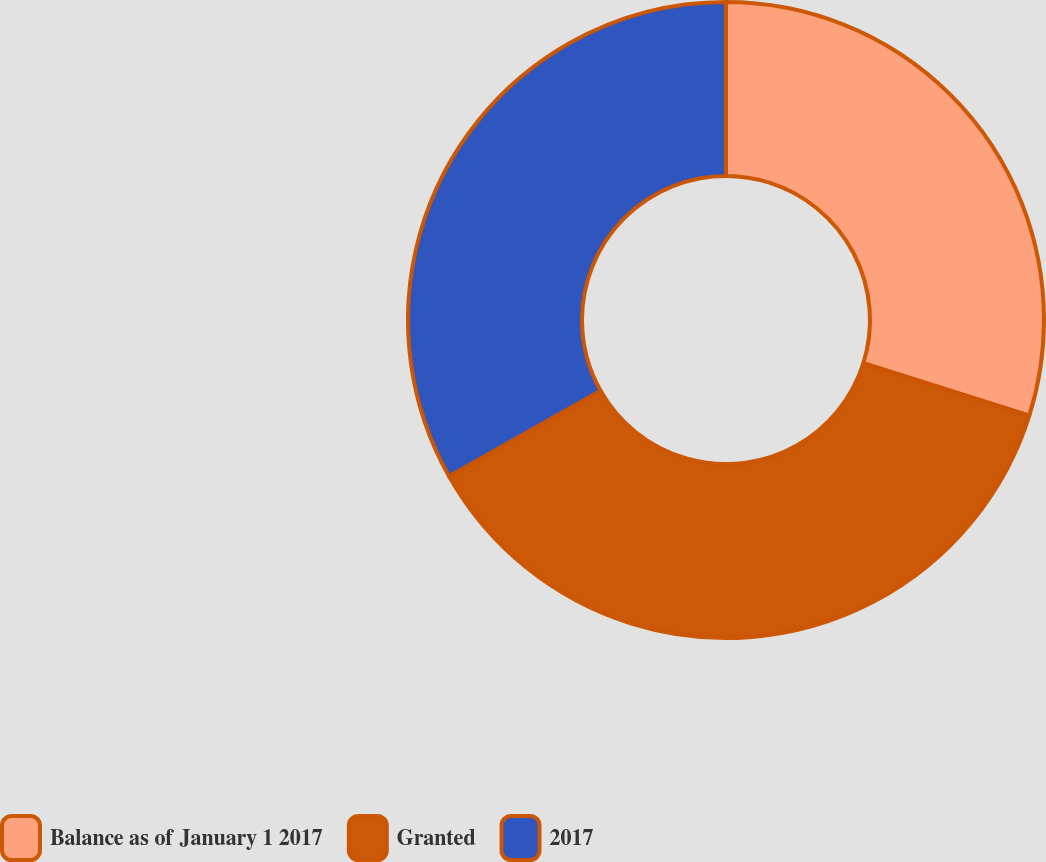Convert chart to OTSL. <chart><loc_0><loc_0><loc_500><loc_500><pie_chart><fcel>Balance as of January 1 2017<fcel>Granted<fcel>2017<nl><fcel>29.86%<fcel>36.97%<fcel>33.18%<nl></chart> 